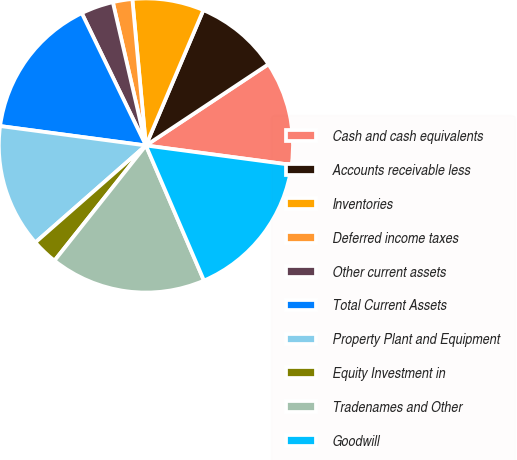Convert chart to OTSL. <chart><loc_0><loc_0><loc_500><loc_500><pie_chart><fcel>Cash and cash equivalents<fcel>Accounts receivable less<fcel>Inventories<fcel>Deferred income taxes<fcel>Other current assets<fcel>Total Current Assets<fcel>Property Plant and Equipment<fcel>Equity Investment in<fcel>Tradenames and Other<fcel>Goodwill<nl><fcel>11.43%<fcel>9.29%<fcel>7.86%<fcel>2.14%<fcel>3.57%<fcel>15.71%<fcel>13.57%<fcel>2.86%<fcel>17.14%<fcel>16.43%<nl></chart> 